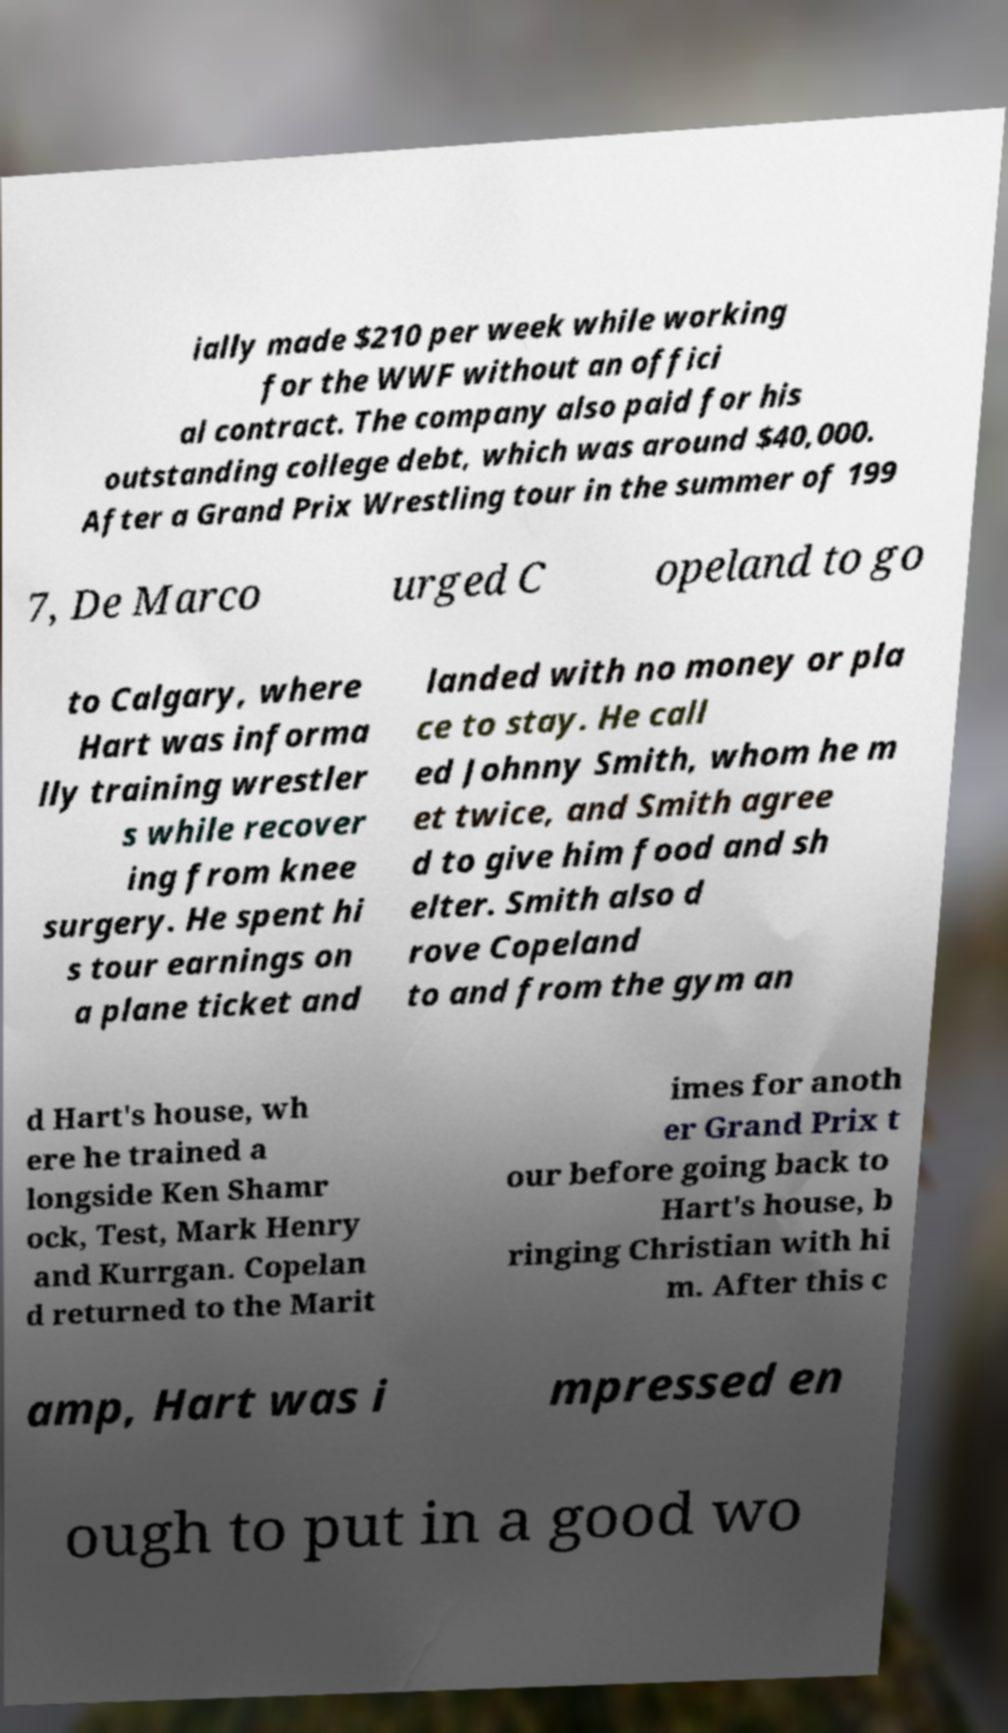Can you read and provide the text displayed in the image?This photo seems to have some interesting text. Can you extract and type it out for me? ially made $210 per week while working for the WWF without an offici al contract. The company also paid for his outstanding college debt, which was around $40,000. After a Grand Prix Wrestling tour in the summer of 199 7, De Marco urged C opeland to go to Calgary, where Hart was informa lly training wrestler s while recover ing from knee surgery. He spent hi s tour earnings on a plane ticket and landed with no money or pla ce to stay. He call ed Johnny Smith, whom he m et twice, and Smith agree d to give him food and sh elter. Smith also d rove Copeland to and from the gym an d Hart's house, wh ere he trained a longside Ken Shamr ock, Test, Mark Henry and Kurrgan. Copelan d returned to the Marit imes for anoth er Grand Prix t our before going back to Hart's house, b ringing Christian with hi m. After this c amp, Hart was i mpressed en ough to put in a good wo 